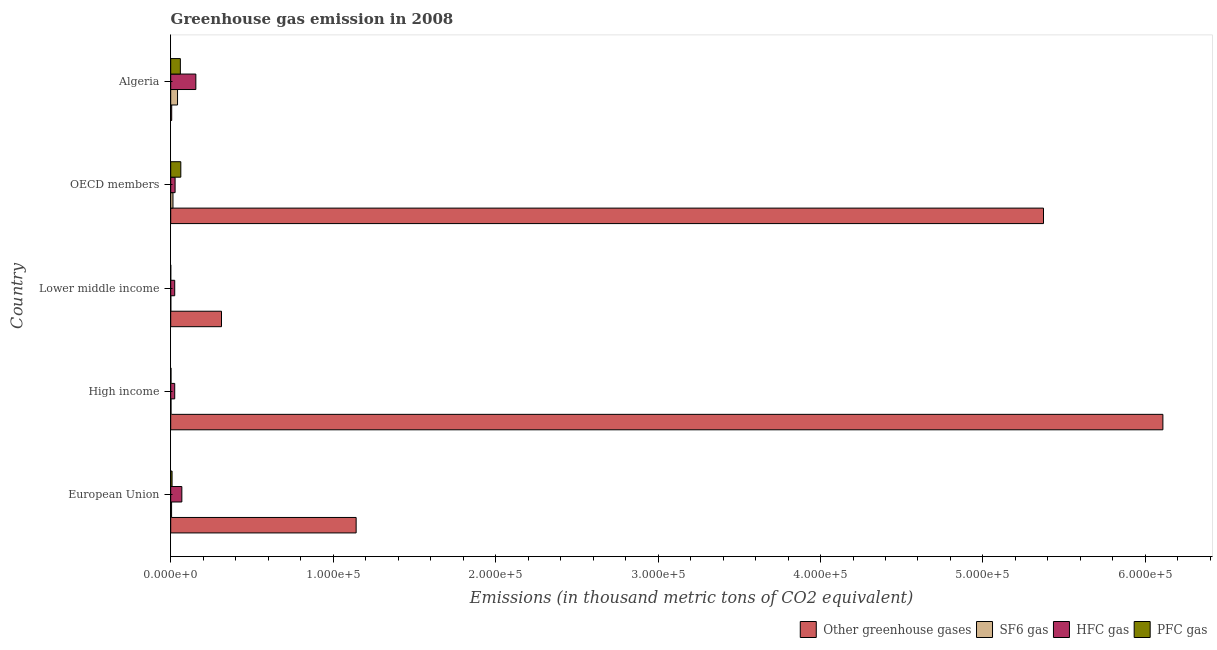How many different coloured bars are there?
Your response must be concise. 4. How many groups of bars are there?
Keep it short and to the point. 5. Are the number of bars on each tick of the Y-axis equal?
Provide a succinct answer. Yes. How many bars are there on the 1st tick from the bottom?
Give a very brief answer. 4. What is the label of the 2nd group of bars from the top?
Keep it short and to the point. OECD members. What is the emission of greenhouse gases in Algeria?
Make the answer very short. 613.9. Across all countries, what is the maximum emission of pfc gas?
Your answer should be very brief. 6221.8. Across all countries, what is the minimum emission of greenhouse gases?
Provide a succinct answer. 613.9. In which country was the emission of sf6 gas maximum?
Offer a terse response. Algeria. In which country was the emission of greenhouse gases minimum?
Your answer should be very brief. Algeria. What is the total emission of sf6 gas in the graph?
Keep it short and to the point. 6427.5. What is the difference between the emission of greenhouse gases in High income and that in OECD members?
Offer a very short reply. 7.35e+04. What is the difference between the emission of sf6 gas in High income and the emission of hfc gas in OECD members?
Keep it short and to the point. -2511.1. What is the average emission of hfc gas per country?
Your answer should be very brief. 5995.94. What is the difference between the emission of greenhouse gases and emission of pfc gas in High income?
Make the answer very short. 6.11e+05. What is the ratio of the emission of hfc gas in Algeria to that in High income?
Your answer should be compact. 6.27. What is the difference between the highest and the second highest emission of sf6 gas?
Your response must be concise. 2811.5. What is the difference between the highest and the lowest emission of hfc gas?
Your answer should be compact. 1.30e+04. What does the 4th bar from the top in Algeria represents?
Your answer should be very brief. Other greenhouse gases. What does the 3rd bar from the bottom in High income represents?
Offer a very short reply. HFC gas. How many bars are there?
Provide a succinct answer. 20. Are the values on the major ticks of X-axis written in scientific E-notation?
Offer a terse response. Yes. Where does the legend appear in the graph?
Offer a very short reply. Bottom right. How many legend labels are there?
Your response must be concise. 4. How are the legend labels stacked?
Give a very brief answer. Horizontal. What is the title of the graph?
Provide a short and direct response. Greenhouse gas emission in 2008. What is the label or title of the X-axis?
Make the answer very short. Emissions (in thousand metric tons of CO2 equivalent). What is the Emissions (in thousand metric tons of CO2 equivalent) in Other greenhouse gases in European Union?
Your answer should be compact. 1.14e+05. What is the Emissions (in thousand metric tons of CO2 equivalent) in SF6 gas in European Union?
Ensure brevity in your answer.  544.1. What is the Emissions (in thousand metric tons of CO2 equivalent) in HFC gas in European Union?
Offer a terse response. 6857.4. What is the Emissions (in thousand metric tons of CO2 equivalent) in PFC gas in European Union?
Your response must be concise. 842. What is the Emissions (in thousand metric tons of CO2 equivalent) of Other greenhouse gases in High income?
Ensure brevity in your answer.  6.11e+05. What is the Emissions (in thousand metric tons of CO2 equivalent) in SF6 gas in High income?
Your answer should be compact. 196.4. What is the Emissions (in thousand metric tons of CO2 equivalent) of HFC gas in High income?
Give a very brief answer. 2468.9. What is the Emissions (in thousand metric tons of CO2 equivalent) in PFC gas in High income?
Your answer should be very brief. 197.1. What is the Emissions (in thousand metric tons of CO2 equivalent) in Other greenhouse gases in Lower middle income?
Offer a terse response. 3.13e+04. What is the Emissions (in thousand metric tons of CO2 equivalent) of SF6 gas in Lower middle income?
Ensure brevity in your answer.  80.9. What is the Emissions (in thousand metric tons of CO2 equivalent) of HFC gas in Lower middle income?
Make the answer very short. 2471.1. What is the Emissions (in thousand metric tons of CO2 equivalent) of Other greenhouse gases in OECD members?
Provide a short and direct response. 5.37e+05. What is the Emissions (in thousand metric tons of CO2 equivalent) of SF6 gas in OECD members?
Ensure brevity in your answer.  1397.3. What is the Emissions (in thousand metric tons of CO2 equivalent) of HFC gas in OECD members?
Provide a short and direct response. 2707.5. What is the Emissions (in thousand metric tons of CO2 equivalent) in PFC gas in OECD members?
Make the answer very short. 6221.8. What is the Emissions (in thousand metric tons of CO2 equivalent) of Other greenhouse gases in Algeria?
Provide a succinct answer. 613.9. What is the Emissions (in thousand metric tons of CO2 equivalent) in SF6 gas in Algeria?
Offer a terse response. 4208.8. What is the Emissions (in thousand metric tons of CO2 equivalent) of HFC gas in Algeria?
Give a very brief answer. 1.55e+04. What is the Emissions (in thousand metric tons of CO2 equivalent) in PFC gas in Algeria?
Your answer should be compact. 5943.7. Across all countries, what is the maximum Emissions (in thousand metric tons of CO2 equivalent) of Other greenhouse gases?
Your answer should be compact. 6.11e+05. Across all countries, what is the maximum Emissions (in thousand metric tons of CO2 equivalent) of SF6 gas?
Make the answer very short. 4208.8. Across all countries, what is the maximum Emissions (in thousand metric tons of CO2 equivalent) of HFC gas?
Ensure brevity in your answer.  1.55e+04. Across all countries, what is the maximum Emissions (in thousand metric tons of CO2 equivalent) of PFC gas?
Offer a very short reply. 6221.8. Across all countries, what is the minimum Emissions (in thousand metric tons of CO2 equivalent) of Other greenhouse gases?
Provide a succinct answer. 613.9. Across all countries, what is the minimum Emissions (in thousand metric tons of CO2 equivalent) in SF6 gas?
Offer a very short reply. 80.9. Across all countries, what is the minimum Emissions (in thousand metric tons of CO2 equivalent) in HFC gas?
Make the answer very short. 2468.9. Across all countries, what is the minimum Emissions (in thousand metric tons of CO2 equivalent) of PFC gas?
Keep it short and to the point. 26. What is the total Emissions (in thousand metric tons of CO2 equivalent) in Other greenhouse gases in the graph?
Provide a short and direct response. 1.29e+06. What is the total Emissions (in thousand metric tons of CO2 equivalent) of SF6 gas in the graph?
Keep it short and to the point. 6427.5. What is the total Emissions (in thousand metric tons of CO2 equivalent) of HFC gas in the graph?
Offer a very short reply. 3.00e+04. What is the total Emissions (in thousand metric tons of CO2 equivalent) of PFC gas in the graph?
Offer a terse response. 1.32e+04. What is the difference between the Emissions (in thousand metric tons of CO2 equivalent) in Other greenhouse gases in European Union and that in High income?
Make the answer very short. -4.97e+05. What is the difference between the Emissions (in thousand metric tons of CO2 equivalent) of SF6 gas in European Union and that in High income?
Give a very brief answer. 347.7. What is the difference between the Emissions (in thousand metric tons of CO2 equivalent) of HFC gas in European Union and that in High income?
Provide a short and direct response. 4388.5. What is the difference between the Emissions (in thousand metric tons of CO2 equivalent) of PFC gas in European Union and that in High income?
Offer a terse response. 644.9. What is the difference between the Emissions (in thousand metric tons of CO2 equivalent) of Other greenhouse gases in European Union and that in Lower middle income?
Provide a succinct answer. 8.29e+04. What is the difference between the Emissions (in thousand metric tons of CO2 equivalent) in SF6 gas in European Union and that in Lower middle income?
Your answer should be very brief. 463.2. What is the difference between the Emissions (in thousand metric tons of CO2 equivalent) in HFC gas in European Union and that in Lower middle income?
Your answer should be compact. 4386.3. What is the difference between the Emissions (in thousand metric tons of CO2 equivalent) in PFC gas in European Union and that in Lower middle income?
Provide a succinct answer. 816. What is the difference between the Emissions (in thousand metric tons of CO2 equivalent) of Other greenhouse gases in European Union and that in OECD members?
Make the answer very short. -4.23e+05. What is the difference between the Emissions (in thousand metric tons of CO2 equivalent) of SF6 gas in European Union and that in OECD members?
Provide a short and direct response. -853.2. What is the difference between the Emissions (in thousand metric tons of CO2 equivalent) of HFC gas in European Union and that in OECD members?
Make the answer very short. 4149.9. What is the difference between the Emissions (in thousand metric tons of CO2 equivalent) of PFC gas in European Union and that in OECD members?
Give a very brief answer. -5379.8. What is the difference between the Emissions (in thousand metric tons of CO2 equivalent) of Other greenhouse gases in European Union and that in Algeria?
Offer a terse response. 1.14e+05. What is the difference between the Emissions (in thousand metric tons of CO2 equivalent) in SF6 gas in European Union and that in Algeria?
Your answer should be very brief. -3664.7. What is the difference between the Emissions (in thousand metric tons of CO2 equivalent) in HFC gas in European Union and that in Algeria?
Ensure brevity in your answer.  -8617.4. What is the difference between the Emissions (in thousand metric tons of CO2 equivalent) in PFC gas in European Union and that in Algeria?
Your response must be concise. -5101.7. What is the difference between the Emissions (in thousand metric tons of CO2 equivalent) in Other greenhouse gases in High income and that in Lower middle income?
Offer a very short reply. 5.79e+05. What is the difference between the Emissions (in thousand metric tons of CO2 equivalent) of SF6 gas in High income and that in Lower middle income?
Keep it short and to the point. 115.5. What is the difference between the Emissions (in thousand metric tons of CO2 equivalent) of HFC gas in High income and that in Lower middle income?
Your answer should be very brief. -2.2. What is the difference between the Emissions (in thousand metric tons of CO2 equivalent) in PFC gas in High income and that in Lower middle income?
Your response must be concise. 171.1. What is the difference between the Emissions (in thousand metric tons of CO2 equivalent) of Other greenhouse gases in High income and that in OECD members?
Your answer should be very brief. 7.35e+04. What is the difference between the Emissions (in thousand metric tons of CO2 equivalent) in SF6 gas in High income and that in OECD members?
Give a very brief answer. -1200.9. What is the difference between the Emissions (in thousand metric tons of CO2 equivalent) of HFC gas in High income and that in OECD members?
Provide a succinct answer. -238.6. What is the difference between the Emissions (in thousand metric tons of CO2 equivalent) in PFC gas in High income and that in OECD members?
Make the answer very short. -6024.7. What is the difference between the Emissions (in thousand metric tons of CO2 equivalent) of Other greenhouse gases in High income and that in Algeria?
Provide a succinct answer. 6.10e+05. What is the difference between the Emissions (in thousand metric tons of CO2 equivalent) in SF6 gas in High income and that in Algeria?
Provide a succinct answer. -4012.4. What is the difference between the Emissions (in thousand metric tons of CO2 equivalent) of HFC gas in High income and that in Algeria?
Your answer should be very brief. -1.30e+04. What is the difference between the Emissions (in thousand metric tons of CO2 equivalent) of PFC gas in High income and that in Algeria?
Your answer should be very brief. -5746.6. What is the difference between the Emissions (in thousand metric tons of CO2 equivalent) in Other greenhouse gases in Lower middle income and that in OECD members?
Keep it short and to the point. -5.06e+05. What is the difference between the Emissions (in thousand metric tons of CO2 equivalent) in SF6 gas in Lower middle income and that in OECD members?
Offer a very short reply. -1316.4. What is the difference between the Emissions (in thousand metric tons of CO2 equivalent) in HFC gas in Lower middle income and that in OECD members?
Offer a very short reply. -236.4. What is the difference between the Emissions (in thousand metric tons of CO2 equivalent) of PFC gas in Lower middle income and that in OECD members?
Provide a short and direct response. -6195.8. What is the difference between the Emissions (in thousand metric tons of CO2 equivalent) in Other greenhouse gases in Lower middle income and that in Algeria?
Ensure brevity in your answer.  3.07e+04. What is the difference between the Emissions (in thousand metric tons of CO2 equivalent) in SF6 gas in Lower middle income and that in Algeria?
Provide a short and direct response. -4127.9. What is the difference between the Emissions (in thousand metric tons of CO2 equivalent) in HFC gas in Lower middle income and that in Algeria?
Give a very brief answer. -1.30e+04. What is the difference between the Emissions (in thousand metric tons of CO2 equivalent) of PFC gas in Lower middle income and that in Algeria?
Your answer should be compact. -5917.7. What is the difference between the Emissions (in thousand metric tons of CO2 equivalent) in Other greenhouse gases in OECD members and that in Algeria?
Provide a succinct answer. 5.37e+05. What is the difference between the Emissions (in thousand metric tons of CO2 equivalent) of SF6 gas in OECD members and that in Algeria?
Your answer should be very brief. -2811.5. What is the difference between the Emissions (in thousand metric tons of CO2 equivalent) in HFC gas in OECD members and that in Algeria?
Give a very brief answer. -1.28e+04. What is the difference between the Emissions (in thousand metric tons of CO2 equivalent) of PFC gas in OECD members and that in Algeria?
Offer a very short reply. 278.1. What is the difference between the Emissions (in thousand metric tons of CO2 equivalent) in Other greenhouse gases in European Union and the Emissions (in thousand metric tons of CO2 equivalent) in SF6 gas in High income?
Make the answer very short. 1.14e+05. What is the difference between the Emissions (in thousand metric tons of CO2 equivalent) in Other greenhouse gases in European Union and the Emissions (in thousand metric tons of CO2 equivalent) in HFC gas in High income?
Give a very brief answer. 1.12e+05. What is the difference between the Emissions (in thousand metric tons of CO2 equivalent) in Other greenhouse gases in European Union and the Emissions (in thousand metric tons of CO2 equivalent) in PFC gas in High income?
Give a very brief answer. 1.14e+05. What is the difference between the Emissions (in thousand metric tons of CO2 equivalent) of SF6 gas in European Union and the Emissions (in thousand metric tons of CO2 equivalent) of HFC gas in High income?
Your answer should be compact. -1924.8. What is the difference between the Emissions (in thousand metric tons of CO2 equivalent) in SF6 gas in European Union and the Emissions (in thousand metric tons of CO2 equivalent) in PFC gas in High income?
Ensure brevity in your answer.  347. What is the difference between the Emissions (in thousand metric tons of CO2 equivalent) in HFC gas in European Union and the Emissions (in thousand metric tons of CO2 equivalent) in PFC gas in High income?
Make the answer very short. 6660.3. What is the difference between the Emissions (in thousand metric tons of CO2 equivalent) of Other greenhouse gases in European Union and the Emissions (in thousand metric tons of CO2 equivalent) of SF6 gas in Lower middle income?
Your answer should be very brief. 1.14e+05. What is the difference between the Emissions (in thousand metric tons of CO2 equivalent) in Other greenhouse gases in European Union and the Emissions (in thousand metric tons of CO2 equivalent) in HFC gas in Lower middle income?
Your response must be concise. 1.12e+05. What is the difference between the Emissions (in thousand metric tons of CO2 equivalent) of Other greenhouse gases in European Union and the Emissions (in thousand metric tons of CO2 equivalent) of PFC gas in Lower middle income?
Your answer should be very brief. 1.14e+05. What is the difference between the Emissions (in thousand metric tons of CO2 equivalent) of SF6 gas in European Union and the Emissions (in thousand metric tons of CO2 equivalent) of HFC gas in Lower middle income?
Your response must be concise. -1927. What is the difference between the Emissions (in thousand metric tons of CO2 equivalent) of SF6 gas in European Union and the Emissions (in thousand metric tons of CO2 equivalent) of PFC gas in Lower middle income?
Offer a very short reply. 518.1. What is the difference between the Emissions (in thousand metric tons of CO2 equivalent) in HFC gas in European Union and the Emissions (in thousand metric tons of CO2 equivalent) in PFC gas in Lower middle income?
Ensure brevity in your answer.  6831.4. What is the difference between the Emissions (in thousand metric tons of CO2 equivalent) in Other greenhouse gases in European Union and the Emissions (in thousand metric tons of CO2 equivalent) in SF6 gas in OECD members?
Keep it short and to the point. 1.13e+05. What is the difference between the Emissions (in thousand metric tons of CO2 equivalent) of Other greenhouse gases in European Union and the Emissions (in thousand metric tons of CO2 equivalent) of HFC gas in OECD members?
Your answer should be compact. 1.11e+05. What is the difference between the Emissions (in thousand metric tons of CO2 equivalent) in Other greenhouse gases in European Union and the Emissions (in thousand metric tons of CO2 equivalent) in PFC gas in OECD members?
Provide a succinct answer. 1.08e+05. What is the difference between the Emissions (in thousand metric tons of CO2 equivalent) of SF6 gas in European Union and the Emissions (in thousand metric tons of CO2 equivalent) of HFC gas in OECD members?
Provide a succinct answer. -2163.4. What is the difference between the Emissions (in thousand metric tons of CO2 equivalent) of SF6 gas in European Union and the Emissions (in thousand metric tons of CO2 equivalent) of PFC gas in OECD members?
Offer a terse response. -5677.7. What is the difference between the Emissions (in thousand metric tons of CO2 equivalent) in HFC gas in European Union and the Emissions (in thousand metric tons of CO2 equivalent) in PFC gas in OECD members?
Offer a terse response. 635.6. What is the difference between the Emissions (in thousand metric tons of CO2 equivalent) of Other greenhouse gases in European Union and the Emissions (in thousand metric tons of CO2 equivalent) of SF6 gas in Algeria?
Make the answer very short. 1.10e+05. What is the difference between the Emissions (in thousand metric tons of CO2 equivalent) of Other greenhouse gases in European Union and the Emissions (in thousand metric tons of CO2 equivalent) of HFC gas in Algeria?
Provide a succinct answer. 9.87e+04. What is the difference between the Emissions (in thousand metric tons of CO2 equivalent) of Other greenhouse gases in European Union and the Emissions (in thousand metric tons of CO2 equivalent) of PFC gas in Algeria?
Provide a short and direct response. 1.08e+05. What is the difference between the Emissions (in thousand metric tons of CO2 equivalent) in SF6 gas in European Union and the Emissions (in thousand metric tons of CO2 equivalent) in HFC gas in Algeria?
Ensure brevity in your answer.  -1.49e+04. What is the difference between the Emissions (in thousand metric tons of CO2 equivalent) in SF6 gas in European Union and the Emissions (in thousand metric tons of CO2 equivalent) in PFC gas in Algeria?
Your answer should be compact. -5399.6. What is the difference between the Emissions (in thousand metric tons of CO2 equivalent) of HFC gas in European Union and the Emissions (in thousand metric tons of CO2 equivalent) of PFC gas in Algeria?
Offer a terse response. 913.7. What is the difference between the Emissions (in thousand metric tons of CO2 equivalent) in Other greenhouse gases in High income and the Emissions (in thousand metric tons of CO2 equivalent) in SF6 gas in Lower middle income?
Give a very brief answer. 6.11e+05. What is the difference between the Emissions (in thousand metric tons of CO2 equivalent) in Other greenhouse gases in High income and the Emissions (in thousand metric tons of CO2 equivalent) in HFC gas in Lower middle income?
Make the answer very short. 6.08e+05. What is the difference between the Emissions (in thousand metric tons of CO2 equivalent) in Other greenhouse gases in High income and the Emissions (in thousand metric tons of CO2 equivalent) in PFC gas in Lower middle income?
Provide a short and direct response. 6.11e+05. What is the difference between the Emissions (in thousand metric tons of CO2 equivalent) of SF6 gas in High income and the Emissions (in thousand metric tons of CO2 equivalent) of HFC gas in Lower middle income?
Offer a terse response. -2274.7. What is the difference between the Emissions (in thousand metric tons of CO2 equivalent) of SF6 gas in High income and the Emissions (in thousand metric tons of CO2 equivalent) of PFC gas in Lower middle income?
Make the answer very short. 170.4. What is the difference between the Emissions (in thousand metric tons of CO2 equivalent) in HFC gas in High income and the Emissions (in thousand metric tons of CO2 equivalent) in PFC gas in Lower middle income?
Provide a short and direct response. 2442.9. What is the difference between the Emissions (in thousand metric tons of CO2 equivalent) of Other greenhouse gases in High income and the Emissions (in thousand metric tons of CO2 equivalent) of SF6 gas in OECD members?
Ensure brevity in your answer.  6.09e+05. What is the difference between the Emissions (in thousand metric tons of CO2 equivalent) in Other greenhouse gases in High income and the Emissions (in thousand metric tons of CO2 equivalent) in HFC gas in OECD members?
Offer a very short reply. 6.08e+05. What is the difference between the Emissions (in thousand metric tons of CO2 equivalent) in Other greenhouse gases in High income and the Emissions (in thousand metric tons of CO2 equivalent) in PFC gas in OECD members?
Provide a short and direct response. 6.05e+05. What is the difference between the Emissions (in thousand metric tons of CO2 equivalent) in SF6 gas in High income and the Emissions (in thousand metric tons of CO2 equivalent) in HFC gas in OECD members?
Your answer should be very brief. -2511.1. What is the difference between the Emissions (in thousand metric tons of CO2 equivalent) of SF6 gas in High income and the Emissions (in thousand metric tons of CO2 equivalent) of PFC gas in OECD members?
Your response must be concise. -6025.4. What is the difference between the Emissions (in thousand metric tons of CO2 equivalent) in HFC gas in High income and the Emissions (in thousand metric tons of CO2 equivalent) in PFC gas in OECD members?
Provide a short and direct response. -3752.9. What is the difference between the Emissions (in thousand metric tons of CO2 equivalent) in Other greenhouse gases in High income and the Emissions (in thousand metric tons of CO2 equivalent) in SF6 gas in Algeria?
Provide a short and direct response. 6.07e+05. What is the difference between the Emissions (in thousand metric tons of CO2 equivalent) of Other greenhouse gases in High income and the Emissions (in thousand metric tons of CO2 equivalent) of HFC gas in Algeria?
Offer a terse response. 5.95e+05. What is the difference between the Emissions (in thousand metric tons of CO2 equivalent) in Other greenhouse gases in High income and the Emissions (in thousand metric tons of CO2 equivalent) in PFC gas in Algeria?
Offer a terse response. 6.05e+05. What is the difference between the Emissions (in thousand metric tons of CO2 equivalent) in SF6 gas in High income and the Emissions (in thousand metric tons of CO2 equivalent) in HFC gas in Algeria?
Offer a very short reply. -1.53e+04. What is the difference between the Emissions (in thousand metric tons of CO2 equivalent) in SF6 gas in High income and the Emissions (in thousand metric tons of CO2 equivalent) in PFC gas in Algeria?
Ensure brevity in your answer.  -5747.3. What is the difference between the Emissions (in thousand metric tons of CO2 equivalent) of HFC gas in High income and the Emissions (in thousand metric tons of CO2 equivalent) of PFC gas in Algeria?
Your response must be concise. -3474.8. What is the difference between the Emissions (in thousand metric tons of CO2 equivalent) of Other greenhouse gases in Lower middle income and the Emissions (in thousand metric tons of CO2 equivalent) of SF6 gas in OECD members?
Give a very brief answer. 2.99e+04. What is the difference between the Emissions (in thousand metric tons of CO2 equivalent) in Other greenhouse gases in Lower middle income and the Emissions (in thousand metric tons of CO2 equivalent) in HFC gas in OECD members?
Your answer should be compact. 2.86e+04. What is the difference between the Emissions (in thousand metric tons of CO2 equivalent) of Other greenhouse gases in Lower middle income and the Emissions (in thousand metric tons of CO2 equivalent) of PFC gas in OECD members?
Keep it short and to the point. 2.50e+04. What is the difference between the Emissions (in thousand metric tons of CO2 equivalent) in SF6 gas in Lower middle income and the Emissions (in thousand metric tons of CO2 equivalent) in HFC gas in OECD members?
Provide a succinct answer. -2626.6. What is the difference between the Emissions (in thousand metric tons of CO2 equivalent) of SF6 gas in Lower middle income and the Emissions (in thousand metric tons of CO2 equivalent) of PFC gas in OECD members?
Keep it short and to the point. -6140.9. What is the difference between the Emissions (in thousand metric tons of CO2 equivalent) of HFC gas in Lower middle income and the Emissions (in thousand metric tons of CO2 equivalent) of PFC gas in OECD members?
Offer a very short reply. -3750.7. What is the difference between the Emissions (in thousand metric tons of CO2 equivalent) of Other greenhouse gases in Lower middle income and the Emissions (in thousand metric tons of CO2 equivalent) of SF6 gas in Algeria?
Offer a very short reply. 2.71e+04. What is the difference between the Emissions (in thousand metric tons of CO2 equivalent) of Other greenhouse gases in Lower middle income and the Emissions (in thousand metric tons of CO2 equivalent) of HFC gas in Algeria?
Your answer should be very brief. 1.58e+04. What is the difference between the Emissions (in thousand metric tons of CO2 equivalent) of Other greenhouse gases in Lower middle income and the Emissions (in thousand metric tons of CO2 equivalent) of PFC gas in Algeria?
Your response must be concise. 2.53e+04. What is the difference between the Emissions (in thousand metric tons of CO2 equivalent) of SF6 gas in Lower middle income and the Emissions (in thousand metric tons of CO2 equivalent) of HFC gas in Algeria?
Give a very brief answer. -1.54e+04. What is the difference between the Emissions (in thousand metric tons of CO2 equivalent) in SF6 gas in Lower middle income and the Emissions (in thousand metric tons of CO2 equivalent) in PFC gas in Algeria?
Your answer should be compact. -5862.8. What is the difference between the Emissions (in thousand metric tons of CO2 equivalent) of HFC gas in Lower middle income and the Emissions (in thousand metric tons of CO2 equivalent) of PFC gas in Algeria?
Make the answer very short. -3472.6. What is the difference between the Emissions (in thousand metric tons of CO2 equivalent) in Other greenhouse gases in OECD members and the Emissions (in thousand metric tons of CO2 equivalent) in SF6 gas in Algeria?
Ensure brevity in your answer.  5.33e+05. What is the difference between the Emissions (in thousand metric tons of CO2 equivalent) of Other greenhouse gases in OECD members and the Emissions (in thousand metric tons of CO2 equivalent) of HFC gas in Algeria?
Your answer should be compact. 5.22e+05. What is the difference between the Emissions (in thousand metric tons of CO2 equivalent) of Other greenhouse gases in OECD members and the Emissions (in thousand metric tons of CO2 equivalent) of PFC gas in Algeria?
Your answer should be very brief. 5.31e+05. What is the difference between the Emissions (in thousand metric tons of CO2 equivalent) of SF6 gas in OECD members and the Emissions (in thousand metric tons of CO2 equivalent) of HFC gas in Algeria?
Provide a short and direct response. -1.41e+04. What is the difference between the Emissions (in thousand metric tons of CO2 equivalent) of SF6 gas in OECD members and the Emissions (in thousand metric tons of CO2 equivalent) of PFC gas in Algeria?
Your answer should be very brief. -4546.4. What is the difference between the Emissions (in thousand metric tons of CO2 equivalent) in HFC gas in OECD members and the Emissions (in thousand metric tons of CO2 equivalent) in PFC gas in Algeria?
Give a very brief answer. -3236.2. What is the average Emissions (in thousand metric tons of CO2 equivalent) of Other greenhouse gases per country?
Your answer should be very brief. 2.59e+05. What is the average Emissions (in thousand metric tons of CO2 equivalent) of SF6 gas per country?
Offer a very short reply. 1285.5. What is the average Emissions (in thousand metric tons of CO2 equivalent) of HFC gas per country?
Your response must be concise. 5995.94. What is the average Emissions (in thousand metric tons of CO2 equivalent) in PFC gas per country?
Make the answer very short. 2646.12. What is the difference between the Emissions (in thousand metric tons of CO2 equivalent) in Other greenhouse gases and Emissions (in thousand metric tons of CO2 equivalent) in SF6 gas in European Union?
Your answer should be compact. 1.14e+05. What is the difference between the Emissions (in thousand metric tons of CO2 equivalent) in Other greenhouse gases and Emissions (in thousand metric tons of CO2 equivalent) in HFC gas in European Union?
Make the answer very short. 1.07e+05. What is the difference between the Emissions (in thousand metric tons of CO2 equivalent) of Other greenhouse gases and Emissions (in thousand metric tons of CO2 equivalent) of PFC gas in European Union?
Offer a terse response. 1.13e+05. What is the difference between the Emissions (in thousand metric tons of CO2 equivalent) of SF6 gas and Emissions (in thousand metric tons of CO2 equivalent) of HFC gas in European Union?
Make the answer very short. -6313.3. What is the difference between the Emissions (in thousand metric tons of CO2 equivalent) of SF6 gas and Emissions (in thousand metric tons of CO2 equivalent) of PFC gas in European Union?
Your answer should be very brief. -297.9. What is the difference between the Emissions (in thousand metric tons of CO2 equivalent) of HFC gas and Emissions (in thousand metric tons of CO2 equivalent) of PFC gas in European Union?
Your answer should be compact. 6015.4. What is the difference between the Emissions (in thousand metric tons of CO2 equivalent) in Other greenhouse gases and Emissions (in thousand metric tons of CO2 equivalent) in SF6 gas in High income?
Provide a short and direct response. 6.11e+05. What is the difference between the Emissions (in thousand metric tons of CO2 equivalent) of Other greenhouse gases and Emissions (in thousand metric tons of CO2 equivalent) of HFC gas in High income?
Provide a succinct answer. 6.08e+05. What is the difference between the Emissions (in thousand metric tons of CO2 equivalent) in Other greenhouse gases and Emissions (in thousand metric tons of CO2 equivalent) in PFC gas in High income?
Your answer should be compact. 6.11e+05. What is the difference between the Emissions (in thousand metric tons of CO2 equivalent) of SF6 gas and Emissions (in thousand metric tons of CO2 equivalent) of HFC gas in High income?
Provide a succinct answer. -2272.5. What is the difference between the Emissions (in thousand metric tons of CO2 equivalent) in HFC gas and Emissions (in thousand metric tons of CO2 equivalent) in PFC gas in High income?
Ensure brevity in your answer.  2271.8. What is the difference between the Emissions (in thousand metric tons of CO2 equivalent) in Other greenhouse gases and Emissions (in thousand metric tons of CO2 equivalent) in SF6 gas in Lower middle income?
Make the answer very short. 3.12e+04. What is the difference between the Emissions (in thousand metric tons of CO2 equivalent) of Other greenhouse gases and Emissions (in thousand metric tons of CO2 equivalent) of HFC gas in Lower middle income?
Your answer should be compact. 2.88e+04. What is the difference between the Emissions (in thousand metric tons of CO2 equivalent) of Other greenhouse gases and Emissions (in thousand metric tons of CO2 equivalent) of PFC gas in Lower middle income?
Give a very brief answer. 3.12e+04. What is the difference between the Emissions (in thousand metric tons of CO2 equivalent) of SF6 gas and Emissions (in thousand metric tons of CO2 equivalent) of HFC gas in Lower middle income?
Keep it short and to the point. -2390.2. What is the difference between the Emissions (in thousand metric tons of CO2 equivalent) of SF6 gas and Emissions (in thousand metric tons of CO2 equivalent) of PFC gas in Lower middle income?
Offer a very short reply. 54.9. What is the difference between the Emissions (in thousand metric tons of CO2 equivalent) in HFC gas and Emissions (in thousand metric tons of CO2 equivalent) in PFC gas in Lower middle income?
Provide a short and direct response. 2445.1. What is the difference between the Emissions (in thousand metric tons of CO2 equivalent) of Other greenhouse gases and Emissions (in thousand metric tons of CO2 equivalent) of SF6 gas in OECD members?
Keep it short and to the point. 5.36e+05. What is the difference between the Emissions (in thousand metric tons of CO2 equivalent) in Other greenhouse gases and Emissions (in thousand metric tons of CO2 equivalent) in HFC gas in OECD members?
Provide a succinct answer. 5.35e+05. What is the difference between the Emissions (in thousand metric tons of CO2 equivalent) of Other greenhouse gases and Emissions (in thousand metric tons of CO2 equivalent) of PFC gas in OECD members?
Make the answer very short. 5.31e+05. What is the difference between the Emissions (in thousand metric tons of CO2 equivalent) of SF6 gas and Emissions (in thousand metric tons of CO2 equivalent) of HFC gas in OECD members?
Your response must be concise. -1310.2. What is the difference between the Emissions (in thousand metric tons of CO2 equivalent) of SF6 gas and Emissions (in thousand metric tons of CO2 equivalent) of PFC gas in OECD members?
Your answer should be very brief. -4824.5. What is the difference between the Emissions (in thousand metric tons of CO2 equivalent) of HFC gas and Emissions (in thousand metric tons of CO2 equivalent) of PFC gas in OECD members?
Offer a terse response. -3514.3. What is the difference between the Emissions (in thousand metric tons of CO2 equivalent) in Other greenhouse gases and Emissions (in thousand metric tons of CO2 equivalent) in SF6 gas in Algeria?
Ensure brevity in your answer.  -3594.9. What is the difference between the Emissions (in thousand metric tons of CO2 equivalent) of Other greenhouse gases and Emissions (in thousand metric tons of CO2 equivalent) of HFC gas in Algeria?
Provide a succinct answer. -1.49e+04. What is the difference between the Emissions (in thousand metric tons of CO2 equivalent) of Other greenhouse gases and Emissions (in thousand metric tons of CO2 equivalent) of PFC gas in Algeria?
Make the answer very short. -5329.8. What is the difference between the Emissions (in thousand metric tons of CO2 equivalent) in SF6 gas and Emissions (in thousand metric tons of CO2 equivalent) in HFC gas in Algeria?
Your answer should be very brief. -1.13e+04. What is the difference between the Emissions (in thousand metric tons of CO2 equivalent) of SF6 gas and Emissions (in thousand metric tons of CO2 equivalent) of PFC gas in Algeria?
Your response must be concise. -1734.9. What is the difference between the Emissions (in thousand metric tons of CO2 equivalent) of HFC gas and Emissions (in thousand metric tons of CO2 equivalent) of PFC gas in Algeria?
Offer a very short reply. 9531.1. What is the ratio of the Emissions (in thousand metric tons of CO2 equivalent) in Other greenhouse gases in European Union to that in High income?
Keep it short and to the point. 0.19. What is the ratio of the Emissions (in thousand metric tons of CO2 equivalent) of SF6 gas in European Union to that in High income?
Provide a succinct answer. 2.77. What is the ratio of the Emissions (in thousand metric tons of CO2 equivalent) in HFC gas in European Union to that in High income?
Give a very brief answer. 2.78. What is the ratio of the Emissions (in thousand metric tons of CO2 equivalent) of PFC gas in European Union to that in High income?
Make the answer very short. 4.27. What is the ratio of the Emissions (in thousand metric tons of CO2 equivalent) of Other greenhouse gases in European Union to that in Lower middle income?
Your response must be concise. 3.65. What is the ratio of the Emissions (in thousand metric tons of CO2 equivalent) in SF6 gas in European Union to that in Lower middle income?
Your response must be concise. 6.73. What is the ratio of the Emissions (in thousand metric tons of CO2 equivalent) in HFC gas in European Union to that in Lower middle income?
Offer a very short reply. 2.77. What is the ratio of the Emissions (in thousand metric tons of CO2 equivalent) of PFC gas in European Union to that in Lower middle income?
Ensure brevity in your answer.  32.38. What is the ratio of the Emissions (in thousand metric tons of CO2 equivalent) in Other greenhouse gases in European Union to that in OECD members?
Ensure brevity in your answer.  0.21. What is the ratio of the Emissions (in thousand metric tons of CO2 equivalent) in SF6 gas in European Union to that in OECD members?
Make the answer very short. 0.39. What is the ratio of the Emissions (in thousand metric tons of CO2 equivalent) of HFC gas in European Union to that in OECD members?
Ensure brevity in your answer.  2.53. What is the ratio of the Emissions (in thousand metric tons of CO2 equivalent) of PFC gas in European Union to that in OECD members?
Provide a succinct answer. 0.14. What is the ratio of the Emissions (in thousand metric tons of CO2 equivalent) of Other greenhouse gases in European Union to that in Algeria?
Your answer should be compact. 185.95. What is the ratio of the Emissions (in thousand metric tons of CO2 equivalent) in SF6 gas in European Union to that in Algeria?
Your answer should be compact. 0.13. What is the ratio of the Emissions (in thousand metric tons of CO2 equivalent) in HFC gas in European Union to that in Algeria?
Your answer should be compact. 0.44. What is the ratio of the Emissions (in thousand metric tons of CO2 equivalent) of PFC gas in European Union to that in Algeria?
Provide a short and direct response. 0.14. What is the ratio of the Emissions (in thousand metric tons of CO2 equivalent) of Other greenhouse gases in High income to that in Lower middle income?
Ensure brevity in your answer.  19.53. What is the ratio of the Emissions (in thousand metric tons of CO2 equivalent) in SF6 gas in High income to that in Lower middle income?
Keep it short and to the point. 2.43. What is the ratio of the Emissions (in thousand metric tons of CO2 equivalent) of PFC gas in High income to that in Lower middle income?
Your answer should be very brief. 7.58. What is the ratio of the Emissions (in thousand metric tons of CO2 equivalent) in Other greenhouse gases in High income to that in OECD members?
Give a very brief answer. 1.14. What is the ratio of the Emissions (in thousand metric tons of CO2 equivalent) of SF6 gas in High income to that in OECD members?
Keep it short and to the point. 0.14. What is the ratio of the Emissions (in thousand metric tons of CO2 equivalent) in HFC gas in High income to that in OECD members?
Your answer should be compact. 0.91. What is the ratio of the Emissions (in thousand metric tons of CO2 equivalent) of PFC gas in High income to that in OECD members?
Make the answer very short. 0.03. What is the ratio of the Emissions (in thousand metric tons of CO2 equivalent) of Other greenhouse gases in High income to that in Algeria?
Keep it short and to the point. 994.87. What is the ratio of the Emissions (in thousand metric tons of CO2 equivalent) in SF6 gas in High income to that in Algeria?
Ensure brevity in your answer.  0.05. What is the ratio of the Emissions (in thousand metric tons of CO2 equivalent) of HFC gas in High income to that in Algeria?
Give a very brief answer. 0.16. What is the ratio of the Emissions (in thousand metric tons of CO2 equivalent) in PFC gas in High income to that in Algeria?
Keep it short and to the point. 0.03. What is the ratio of the Emissions (in thousand metric tons of CO2 equivalent) in Other greenhouse gases in Lower middle income to that in OECD members?
Your answer should be very brief. 0.06. What is the ratio of the Emissions (in thousand metric tons of CO2 equivalent) of SF6 gas in Lower middle income to that in OECD members?
Give a very brief answer. 0.06. What is the ratio of the Emissions (in thousand metric tons of CO2 equivalent) of HFC gas in Lower middle income to that in OECD members?
Ensure brevity in your answer.  0.91. What is the ratio of the Emissions (in thousand metric tons of CO2 equivalent) of PFC gas in Lower middle income to that in OECD members?
Offer a very short reply. 0. What is the ratio of the Emissions (in thousand metric tons of CO2 equivalent) in Other greenhouse gases in Lower middle income to that in Algeria?
Your response must be concise. 50.93. What is the ratio of the Emissions (in thousand metric tons of CO2 equivalent) in SF6 gas in Lower middle income to that in Algeria?
Provide a short and direct response. 0.02. What is the ratio of the Emissions (in thousand metric tons of CO2 equivalent) of HFC gas in Lower middle income to that in Algeria?
Provide a succinct answer. 0.16. What is the ratio of the Emissions (in thousand metric tons of CO2 equivalent) of PFC gas in Lower middle income to that in Algeria?
Offer a terse response. 0. What is the ratio of the Emissions (in thousand metric tons of CO2 equivalent) in Other greenhouse gases in OECD members to that in Algeria?
Give a very brief answer. 875.16. What is the ratio of the Emissions (in thousand metric tons of CO2 equivalent) of SF6 gas in OECD members to that in Algeria?
Keep it short and to the point. 0.33. What is the ratio of the Emissions (in thousand metric tons of CO2 equivalent) in HFC gas in OECD members to that in Algeria?
Provide a short and direct response. 0.17. What is the ratio of the Emissions (in thousand metric tons of CO2 equivalent) of PFC gas in OECD members to that in Algeria?
Provide a succinct answer. 1.05. What is the difference between the highest and the second highest Emissions (in thousand metric tons of CO2 equivalent) in Other greenhouse gases?
Offer a very short reply. 7.35e+04. What is the difference between the highest and the second highest Emissions (in thousand metric tons of CO2 equivalent) of SF6 gas?
Give a very brief answer. 2811.5. What is the difference between the highest and the second highest Emissions (in thousand metric tons of CO2 equivalent) of HFC gas?
Give a very brief answer. 8617.4. What is the difference between the highest and the second highest Emissions (in thousand metric tons of CO2 equivalent) in PFC gas?
Your answer should be compact. 278.1. What is the difference between the highest and the lowest Emissions (in thousand metric tons of CO2 equivalent) in Other greenhouse gases?
Provide a short and direct response. 6.10e+05. What is the difference between the highest and the lowest Emissions (in thousand metric tons of CO2 equivalent) of SF6 gas?
Ensure brevity in your answer.  4127.9. What is the difference between the highest and the lowest Emissions (in thousand metric tons of CO2 equivalent) in HFC gas?
Keep it short and to the point. 1.30e+04. What is the difference between the highest and the lowest Emissions (in thousand metric tons of CO2 equivalent) of PFC gas?
Your response must be concise. 6195.8. 